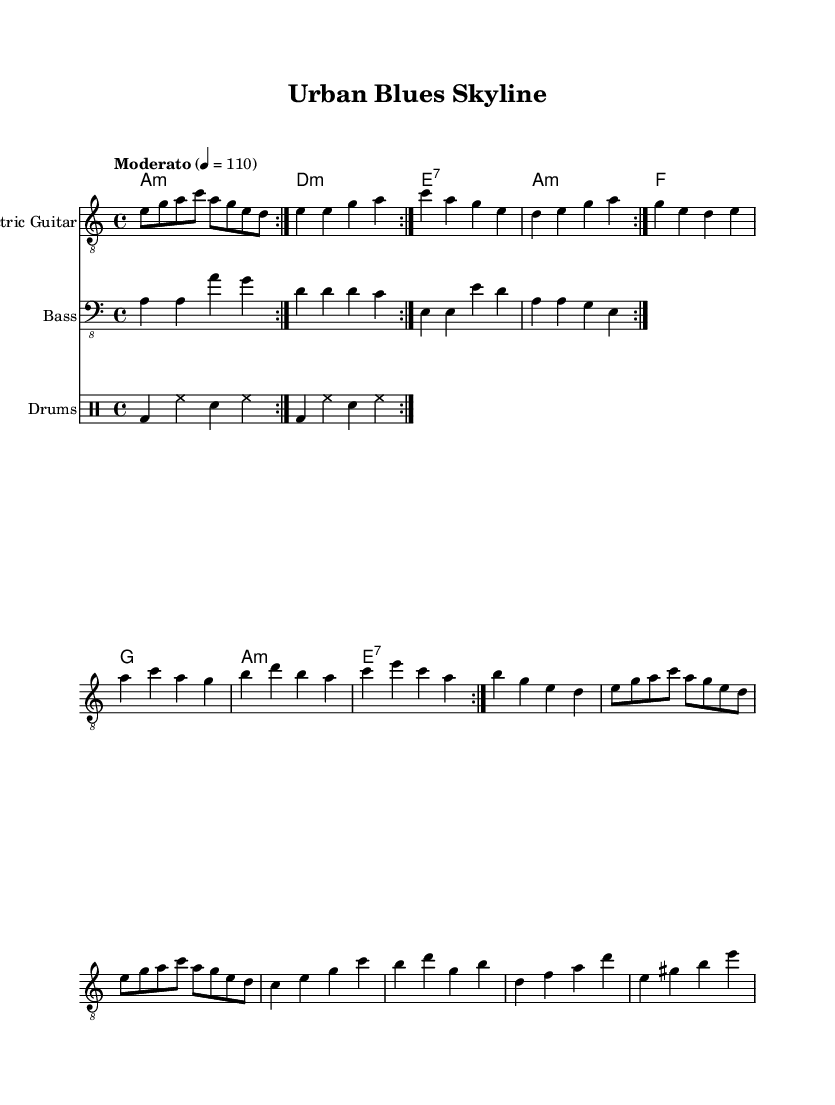What is the key signature of this music? The key signature is A minor, indicated by the absence of sharps or flats in the key area. This can be confirmed by checking the clef and key signature markings at the beginning of the staff.
Answer: A minor What is the time signature of this music? The time signature is 4/4, which means there are four beats in each measure and the quarter note receives one beat. This can be seen at the beginning of the score where the time signature is marked.
Answer: 4/4 What is the tempo marking of this music? The tempo marking is "Moderato" with a metronome marking of 110 beats per minute, indicating a moderate pace. This appears at the top section of the score, providing performers with the speed at which to play.
Answer: Moderato How many measures are in the Guitar Riff section? There are 8 measures in the Guitar Riff section as it repeats twice, each containing 4 beats which can be counted by analyzing the notation for the electric guitar at the beginning of the piece.
Answer: 8 What are the main chords used in the organ section? The main chords used in the organ section include A minor, D minor, E seventh, and F major, which can be found by examining the chord names listed for the organ part in the score.
Answer: A minor, D minor, E seventh, F major Which instrument has a solo section? The electric guitar has a solo section indicated by a specific passage in the notation where the guitar plays a series of notes without additional accompaniment, highlighting the expressive qualities typical in Blues music.
Answer: Electric Guitar How does the bass line interact with the drums? The bass line interacts with the drums by providing a steady rhythmic foundation that complements the drum pattern. The pattern repeats and aligns with the drum rhythms, which makes the overall groove feel cohesive, a common characteristic of Electric Blues.
Answer: Steady rhythmic foundation 